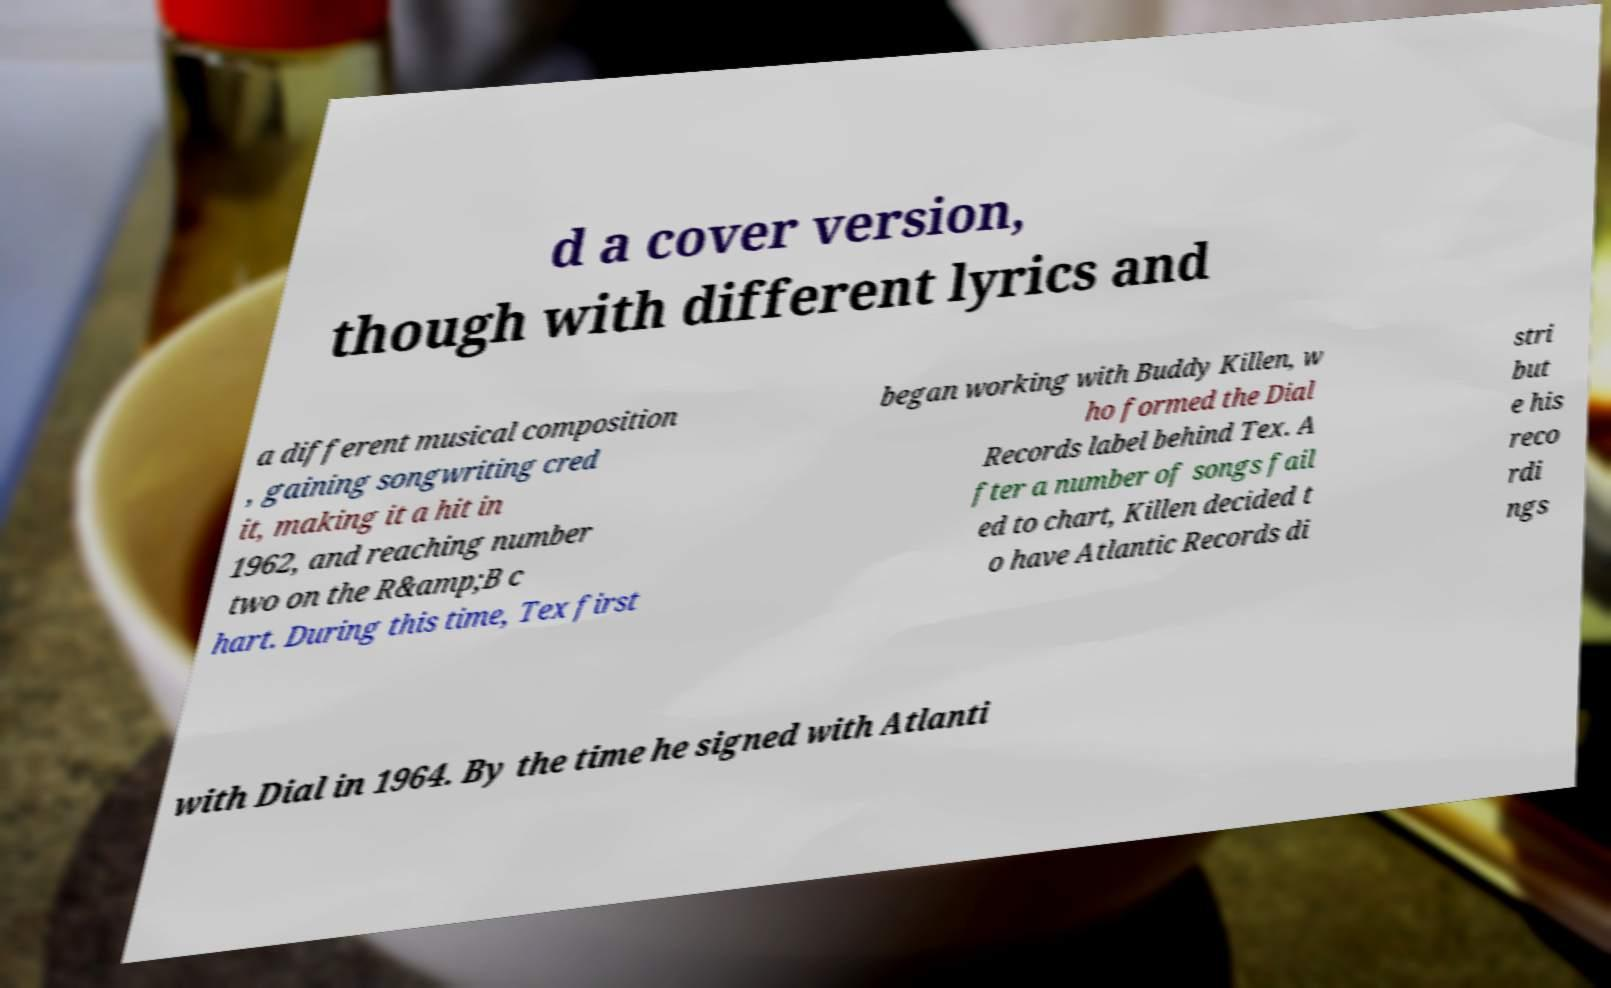Please identify and transcribe the text found in this image. d a cover version, though with different lyrics and a different musical composition , gaining songwriting cred it, making it a hit in 1962, and reaching number two on the R&amp;B c hart. During this time, Tex first began working with Buddy Killen, w ho formed the Dial Records label behind Tex. A fter a number of songs fail ed to chart, Killen decided t o have Atlantic Records di stri but e his reco rdi ngs with Dial in 1964. By the time he signed with Atlanti 